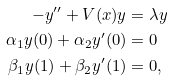<formula> <loc_0><loc_0><loc_500><loc_500>- y ^ { \prime \prime } + V ( x ) y & = \lambda y \\ \alpha _ { 1 } y ( 0 ) + \alpha _ { 2 } y ^ { \prime } ( 0 ) & = 0 \\ \beta _ { 1 } y ( 1 ) + \beta _ { 2 } y ^ { \prime } ( 1 ) & = 0 ,</formula> 